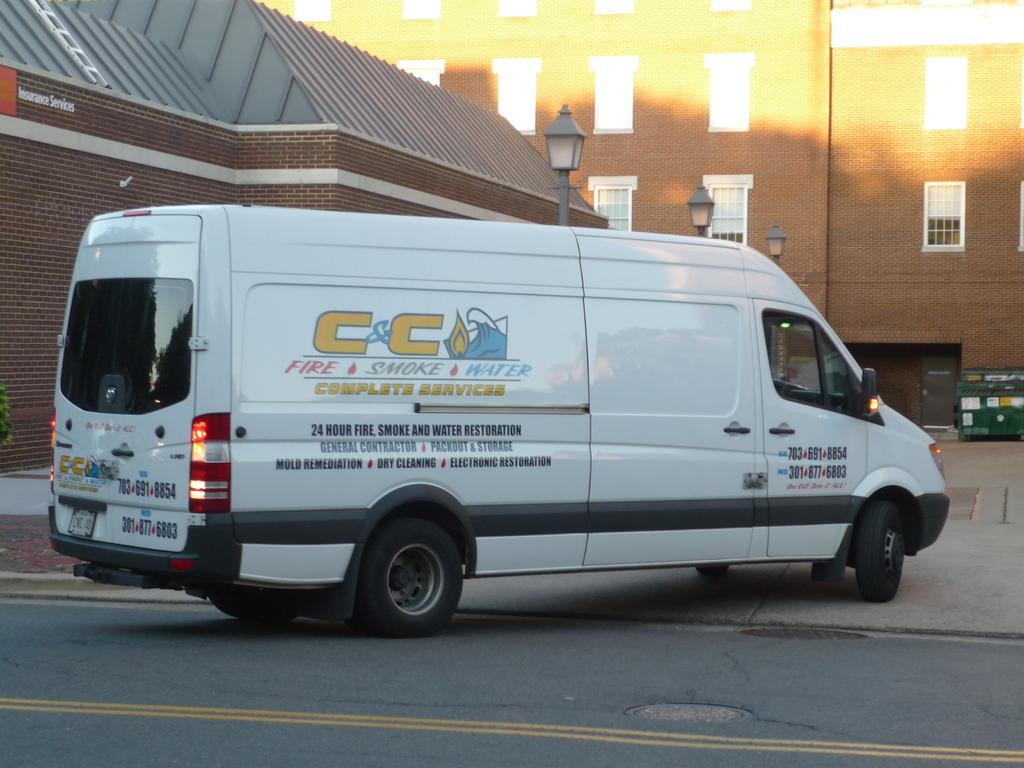Provide a one-sentence caption for the provided image. A white cargo van with a C&C logo on it. 